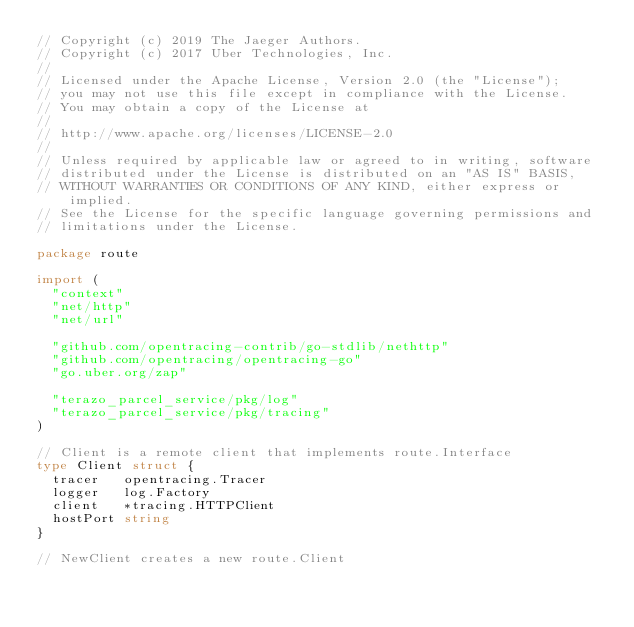Convert code to text. <code><loc_0><loc_0><loc_500><loc_500><_Go_>// Copyright (c) 2019 The Jaeger Authors.
// Copyright (c) 2017 Uber Technologies, Inc.
//
// Licensed under the Apache License, Version 2.0 (the "License");
// you may not use this file except in compliance with the License.
// You may obtain a copy of the License at
//
// http://www.apache.org/licenses/LICENSE-2.0
//
// Unless required by applicable law or agreed to in writing, software
// distributed under the License is distributed on an "AS IS" BASIS,
// WITHOUT WARRANTIES OR CONDITIONS OF ANY KIND, either express or implied.
// See the License for the specific language governing permissions and
// limitations under the License.

package route

import (
	"context"
	"net/http"
	"net/url"

	"github.com/opentracing-contrib/go-stdlib/nethttp"
	"github.com/opentracing/opentracing-go"
	"go.uber.org/zap"

	"terazo_parcel_service/pkg/log"
	"terazo_parcel_service/pkg/tracing"
)

// Client is a remote client that implements route.Interface
type Client struct {
	tracer   opentracing.Tracer
	logger   log.Factory
	client   *tracing.HTTPClient
	hostPort string
}

// NewClient creates a new route.Client</code> 